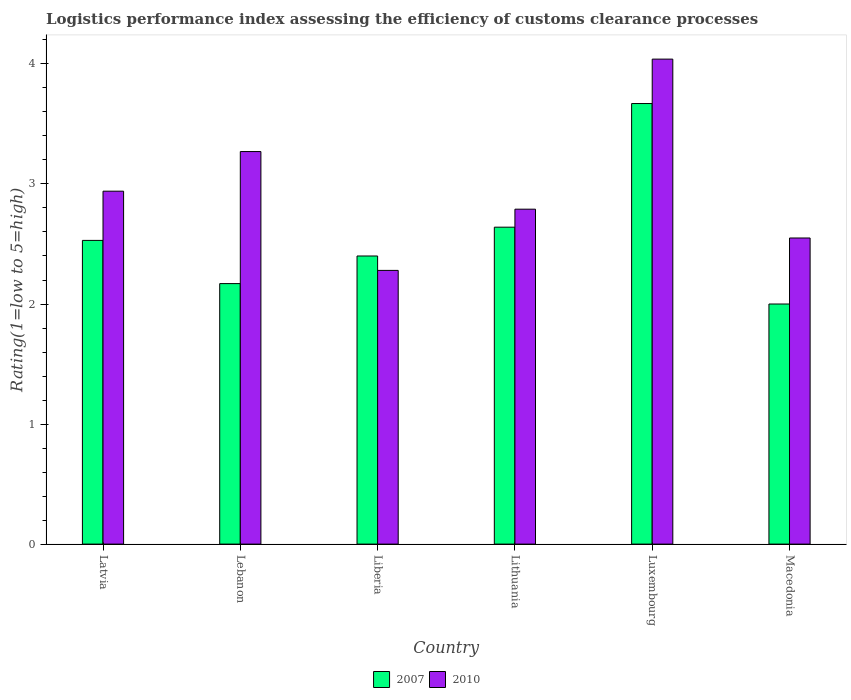How many different coloured bars are there?
Your response must be concise. 2. How many groups of bars are there?
Give a very brief answer. 6. Are the number of bars per tick equal to the number of legend labels?
Your response must be concise. Yes. How many bars are there on the 3rd tick from the left?
Make the answer very short. 2. How many bars are there on the 6th tick from the right?
Your answer should be very brief. 2. What is the label of the 1st group of bars from the left?
Keep it short and to the point. Latvia. What is the Logistic performance index in 2010 in Macedonia?
Provide a short and direct response. 2.55. Across all countries, what is the maximum Logistic performance index in 2007?
Ensure brevity in your answer.  3.67. Across all countries, what is the minimum Logistic performance index in 2007?
Provide a short and direct response. 2. In which country was the Logistic performance index in 2010 maximum?
Make the answer very short. Luxembourg. In which country was the Logistic performance index in 2007 minimum?
Your answer should be very brief. Macedonia. What is the total Logistic performance index in 2010 in the graph?
Offer a very short reply. 17.87. What is the difference between the Logistic performance index in 2010 in Liberia and that in Macedonia?
Make the answer very short. -0.27. What is the difference between the Logistic performance index in 2010 in Lebanon and the Logistic performance index in 2007 in Liberia?
Your answer should be very brief. 0.87. What is the average Logistic performance index in 2007 per country?
Your answer should be very brief. 2.57. What is the difference between the Logistic performance index of/in 2007 and Logistic performance index of/in 2010 in Macedonia?
Provide a succinct answer. -0.55. In how many countries, is the Logistic performance index in 2007 greater than 2.2?
Provide a succinct answer. 4. What is the ratio of the Logistic performance index in 2007 in Latvia to that in Lithuania?
Your answer should be compact. 0.96. Is the Logistic performance index in 2007 in Lithuania less than that in Luxembourg?
Your answer should be compact. Yes. Is the difference between the Logistic performance index in 2007 in Lebanon and Macedonia greater than the difference between the Logistic performance index in 2010 in Lebanon and Macedonia?
Your answer should be very brief. No. What is the difference between the highest and the second highest Logistic performance index in 2010?
Provide a succinct answer. -0.33. What is the difference between the highest and the lowest Logistic performance index in 2007?
Keep it short and to the point. 1.67. In how many countries, is the Logistic performance index in 2010 greater than the average Logistic performance index in 2010 taken over all countries?
Keep it short and to the point. 2. Is the sum of the Logistic performance index in 2010 in Liberia and Luxembourg greater than the maximum Logistic performance index in 2007 across all countries?
Provide a succinct answer. Yes. What does the 2nd bar from the right in Macedonia represents?
Give a very brief answer. 2007. How many bars are there?
Your answer should be compact. 12. How many countries are there in the graph?
Keep it short and to the point. 6. What is the difference between two consecutive major ticks on the Y-axis?
Give a very brief answer. 1. Are the values on the major ticks of Y-axis written in scientific E-notation?
Keep it short and to the point. No. Does the graph contain any zero values?
Your response must be concise. No. What is the title of the graph?
Your response must be concise. Logistics performance index assessing the efficiency of customs clearance processes. Does "2006" appear as one of the legend labels in the graph?
Your response must be concise. No. What is the label or title of the X-axis?
Provide a short and direct response. Country. What is the label or title of the Y-axis?
Provide a succinct answer. Rating(1=low to 5=high). What is the Rating(1=low to 5=high) in 2007 in Latvia?
Your answer should be very brief. 2.53. What is the Rating(1=low to 5=high) in 2010 in Latvia?
Make the answer very short. 2.94. What is the Rating(1=low to 5=high) in 2007 in Lebanon?
Your response must be concise. 2.17. What is the Rating(1=low to 5=high) of 2010 in Lebanon?
Offer a terse response. 3.27. What is the Rating(1=low to 5=high) of 2010 in Liberia?
Your answer should be compact. 2.28. What is the Rating(1=low to 5=high) of 2007 in Lithuania?
Provide a succinct answer. 2.64. What is the Rating(1=low to 5=high) of 2010 in Lithuania?
Your response must be concise. 2.79. What is the Rating(1=low to 5=high) of 2007 in Luxembourg?
Your answer should be compact. 3.67. What is the Rating(1=low to 5=high) of 2010 in Luxembourg?
Offer a very short reply. 4.04. What is the Rating(1=low to 5=high) of 2010 in Macedonia?
Ensure brevity in your answer.  2.55. Across all countries, what is the maximum Rating(1=low to 5=high) of 2007?
Ensure brevity in your answer.  3.67. Across all countries, what is the maximum Rating(1=low to 5=high) of 2010?
Ensure brevity in your answer.  4.04. Across all countries, what is the minimum Rating(1=low to 5=high) in 2007?
Keep it short and to the point. 2. Across all countries, what is the minimum Rating(1=low to 5=high) of 2010?
Offer a very short reply. 2.28. What is the total Rating(1=low to 5=high) of 2007 in the graph?
Give a very brief answer. 15.41. What is the total Rating(1=low to 5=high) in 2010 in the graph?
Make the answer very short. 17.87. What is the difference between the Rating(1=low to 5=high) of 2007 in Latvia and that in Lebanon?
Ensure brevity in your answer.  0.36. What is the difference between the Rating(1=low to 5=high) in 2010 in Latvia and that in Lebanon?
Your response must be concise. -0.33. What is the difference between the Rating(1=low to 5=high) of 2007 in Latvia and that in Liberia?
Provide a succinct answer. 0.13. What is the difference between the Rating(1=low to 5=high) in 2010 in Latvia and that in Liberia?
Your answer should be very brief. 0.66. What is the difference between the Rating(1=low to 5=high) of 2007 in Latvia and that in Lithuania?
Provide a succinct answer. -0.11. What is the difference between the Rating(1=low to 5=high) of 2007 in Latvia and that in Luxembourg?
Your answer should be compact. -1.14. What is the difference between the Rating(1=low to 5=high) in 2010 in Latvia and that in Luxembourg?
Give a very brief answer. -1.1. What is the difference between the Rating(1=low to 5=high) in 2007 in Latvia and that in Macedonia?
Your response must be concise. 0.53. What is the difference between the Rating(1=low to 5=high) in 2010 in Latvia and that in Macedonia?
Make the answer very short. 0.39. What is the difference between the Rating(1=low to 5=high) in 2007 in Lebanon and that in Liberia?
Your answer should be compact. -0.23. What is the difference between the Rating(1=low to 5=high) in 2010 in Lebanon and that in Liberia?
Your response must be concise. 0.99. What is the difference between the Rating(1=low to 5=high) in 2007 in Lebanon and that in Lithuania?
Your answer should be very brief. -0.47. What is the difference between the Rating(1=low to 5=high) of 2010 in Lebanon and that in Lithuania?
Your answer should be compact. 0.48. What is the difference between the Rating(1=low to 5=high) in 2010 in Lebanon and that in Luxembourg?
Your response must be concise. -0.77. What is the difference between the Rating(1=low to 5=high) in 2007 in Lebanon and that in Macedonia?
Offer a terse response. 0.17. What is the difference between the Rating(1=low to 5=high) in 2010 in Lebanon and that in Macedonia?
Give a very brief answer. 0.72. What is the difference between the Rating(1=low to 5=high) of 2007 in Liberia and that in Lithuania?
Offer a terse response. -0.24. What is the difference between the Rating(1=low to 5=high) of 2010 in Liberia and that in Lithuania?
Your answer should be compact. -0.51. What is the difference between the Rating(1=low to 5=high) in 2007 in Liberia and that in Luxembourg?
Your answer should be very brief. -1.27. What is the difference between the Rating(1=low to 5=high) in 2010 in Liberia and that in Luxembourg?
Provide a short and direct response. -1.76. What is the difference between the Rating(1=low to 5=high) in 2010 in Liberia and that in Macedonia?
Your answer should be compact. -0.27. What is the difference between the Rating(1=low to 5=high) in 2007 in Lithuania and that in Luxembourg?
Your answer should be compact. -1.03. What is the difference between the Rating(1=low to 5=high) in 2010 in Lithuania and that in Luxembourg?
Your answer should be compact. -1.25. What is the difference between the Rating(1=low to 5=high) in 2007 in Lithuania and that in Macedonia?
Provide a succinct answer. 0.64. What is the difference between the Rating(1=low to 5=high) of 2010 in Lithuania and that in Macedonia?
Your answer should be compact. 0.24. What is the difference between the Rating(1=low to 5=high) in 2007 in Luxembourg and that in Macedonia?
Offer a terse response. 1.67. What is the difference between the Rating(1=low to 5=high) of 2010 in Luxembourg and that in Macedonia?
Your response must be concise. 1.49. What is the difference between the Rating(1=low to 5=high) of 2007 in Latvia and the Rating(1=low to 5=high) of 2010 in Lebanon?
Your response must be concise. -0.74. What is the difference between the Rating(1=low to 5=high) in 2007 in Latvia and the Rating(1=low to 5=high) in 2010 in Lithuania?
Your response must be concise. -0.26. What is the difference between the Rating(1=low to 5=high) in 2007 in Latvia and the Rating(1=low to 5=high) in 2010 in Luxembourg?
Give a very brief answer. -1.51. What is the difference between the Rating(1=low to 5=high) in 2007 in Latvia and the Rating(1=low to 5=high) in 2010 in Macedonia?
Give a very brief answer. -0.02. What is the difference between the Rating(1=low to 5=high) of 2007 in Lebanon and the Rating(1=low to 5=high) of 2010 in Liberia?
Offer a terse response. -0.11. What is the difference between the Rating(1=low to 5=high) of 2007 in Lebanon and the Rating(1=low to 5=high) of 2010 in Lithuania?
Your answer should be very brief. -0.62. What is the difference between the Rating(1=low to 5=high) in 2007 in Lebanon and the Rating(1=low to 5=high) in 2010 in Luxembourg?
Provide a short and direct response. -1.87. What is the difference between the Rating(1=low to 5=high) in 2007 in Lebanon and the Rating(1=low to 5=high) in 2010 in Macedonia?
Your answer should be very brief. -0.38. What is the difference between the Rating(1=low to 5=high) of 2007 in Liberia and the Rating(1=low to 5=high) of 2010 in Lithuania?
Make the answer very short. -0.39. What is the difference between the Rating(1=low to 5=high) in 2007 in Liberia and the Rating(1=low to 5=high) in 2010 in Luxembourg?
Offer a very short reply. -1.64. What is the difference between the Rating(1=low to 5=high) in 2007 in Lithuania and the Rating(1=low to 5=high) in 2010 in Luxembourg?
Your answer should be very brief. -1.4. What is the difference between the Rating(1=low to 5=high) in 2007 in Lithuania and the Rating(1=low to 5=high) in 2010 in Macedonia?
Your answer should be very brief. 0.09. What is the difference between the Rating(1=low to 5=high) of 2007 in Luxembourg and the Rating(1=low to 5=high) of 2010 in Macedonia?
Ensure brevity in your answer.  1.12. What is the average Rating(1=low to 5=high) in 2007 per country?
Provide a succinct answer. 2.57. What is the average Rating(1=low to 5=high) of 2010 per country?
Your response must be concise. 2.98. What is the difference between the Rating(1=low to 5=high) in 2007 and Rating(1=low to 5=high) in 2010 in Latvia?
Your answer should be very brief. -0.41. What is the difference between the Rating(1=low to 5=high) of 2007 and Rating(1=low to 5=high) of 2010 in Lebanon?
Ensure brevity in your answer.  -1.1. What is the difference between the Rating(1=low to 5=high) in 2007 and Rating(1=low to 5=high) in 2010 in Liberia?
Make the answer very short. 0.12. What is the difference between the Rating(1=low to 5=high) in 2007 and Rating(1=low to 5=high) in 2010 in Lithuania?
Your answer should be compact. -0.15. What is the difference between the Rating(1=low to 5=high) in 2007 and Rating(1=low to 5=high) in 2010 in Luxembourg?
Offer a terse response. -0.37. What is the difference between the Rating(1=low to 5=high) in 2007 and Rating(1=low to 5=high) in 2010 in Macedonia?
Provide a short and direct response. -0.55. What is the ratio of the Rating(1=low to 5=high) of 2007 in Latvia to that in Lebanon?
Ensure brevity in your answer.  1.17. What is the ratio of the Rating(1=low to 5=high) of 2010 in Latvia to that in Lebanon?
Make the answer very short. 0.9. What is the ratio of the Rating(1=low to 5=high) of 2007 in Latvia to that in Liberia?
Your answer should be very brief. 1.05. What is the ratio of the Rating(1=low to 5=high) in 2010 in Latvia to that in Liberia?
Offer a terse response. 1.29. What is the ratio of the Rating(1=low to 5=high) in 2010 in Latvia to that in Lithuania?
Keep it short and to the point. 1.05. What is the ratio of the Rating(1=low to 5=high) of 2007 in Latvia to that in Luxembourg?
Give a very brief answer. 0.69. What is the ratio of the Rating(1=low to 5=high) of 2010 in Latvia to that in Luxembourg?
Offer a terse response. 0.73. What is the ratio of the Rating(1=low to 5=high) in 2007 in Latvia to that in Macedonia?
Offer a terse response. 1.26. What is the ratio of the Rating(1=low to 5=high) of 2010 in Latvia to that in Macedonia?
Your response must be concise. 1.15. What is the ratio of the Rating(1=low to 5=high) in 2007 in Lebanon to that in Liberia?
Your answer should be very brief. 0.9. What is the ratio of the Rating(1=low to 5=high) of 2010 in Lebanon to that in Liberia?
Your answer should be compact. 1.43. What is the ratio of the Rating(1=low to 5=high) in 2007 in Lebanon to that in Lithuania?
Keep it short and to the point. 0.82. What is the ratio of the Rating(1=low to 5=high) of 2010 in Lebanon to that in Lithuania?
Keep it short and to the point. 1.17. What is the ratio of the Rating(1=low to 5=high) of 2007 in Lebanon to that in Luxembourg?
Keep it short and to the point. 0.59. What is the ratio of the Rating(1=low to 5=high) in 2010 in Lebanon to that in Luxembourg?
Offer a very short reply. 0.81. What is the ratio of the Rating(1=low to 5=high) in 2007 in Lebanon to that in Macedonia?
Give a very brief answer. 1.08. What is the ratio of the Rating(1=low to 5=high) of 2010 in Lebanon to that in Macedonia?
Provide a succinct answer. 1.28. What is the ratio of the Rating(1=low to 5=high) in 2010 in Liberia to that in Lithuania?
Ensure brevity in your answer.  0.82. What is the ratio of the Rating(1=low to 5=high) of 2007 in Liberia to that in Luxembourg?
Keep it short and to the point. 0.65. What is the ratio of the Rating(1=low to 5=high) of 2010 in Liberia to that in Luxembourg?
Offer a terse response. 0.56. What is the ratio of the Rating(1=low to 5=high) in 2007 in Liberia to that in Macedonia?
Offer a very short reply. 1.2. What is the ratio of the Rating(1=low to 5=high) of 2010 in Liberia to that in Macedonia?
Offer a very short reply. 0.89. What is the ratio of the Rating(1=low to 5=high) in 2007 in Lithuania to that in Luxembourg?
Your response must be concise. 0.72. What is the ratio of the Rating(1=low to 5=high) of 2010 in Lithuania to that in Luxembourg?
Your answer should be compact. 0.69. What is the ratio of the Rating(1=low to 5=high) of 2007 in Lithuania to that in Macedonia?
Provide a succinct answer. 1.32. What is the ratio of the Rating(1=low to 5=high) of 2010 in Lithuania to that in Macedonia?
Offer a very short reply. 1.09. What is the ratio of the Rating(1=low to 5=high) of 2007 in Luxembourg to that in Macedonia?
Provide a succinct answer. 1.83. What is the ratio of the Rating(1=low to 5=high) of 2010 in Luxembourg to that in Macedonia?
Your answer should be very brief. 1.58. What is the difference between the highest and the second highest Rating(1=low to 5=high) of 2010?
Your answer should be compact. 0.77. What is the difference between the highest and the lowest Rating(1=low to 5=high) in 2007?
Provide a succinct answer. 1.67. What is the difference between the highest and the lowest Rating(1=low to 5=high) of 2010?
Provide a succinct answer. 1.76. 